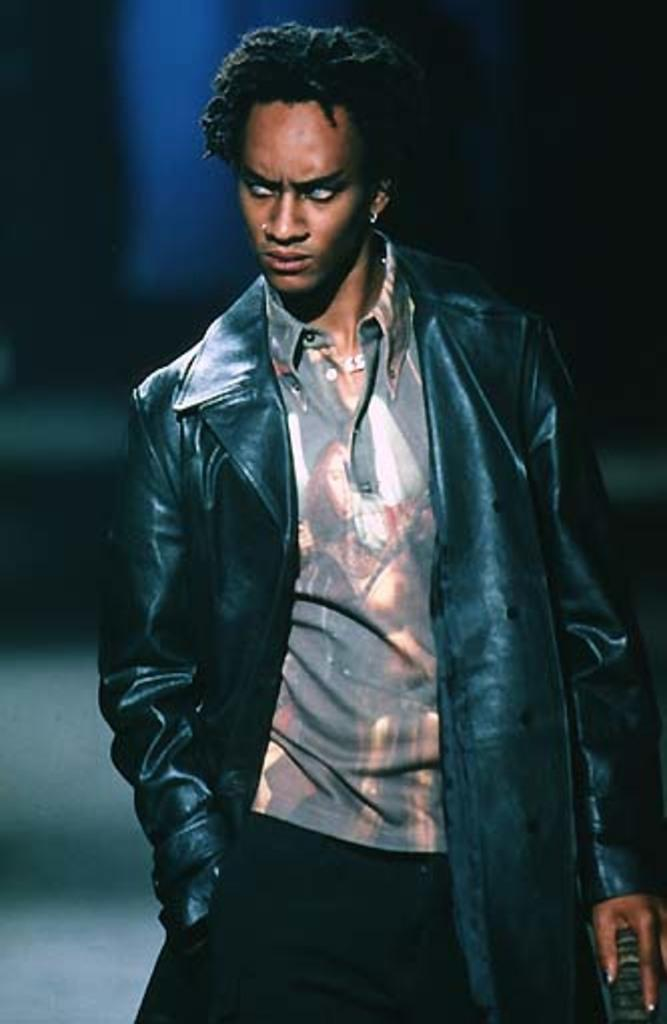Who or what is the main subject in the image? There is a person in the image. What is the person wearing? The person is wearing a jacket. What is the person's posture in the image? The person is standing. Can you describe the background of the image? The background of the image is blurred. What type of power source is visible in the image? There is no power source visible in the image; it features a person wearing a jacket and standing in a blurred background. 